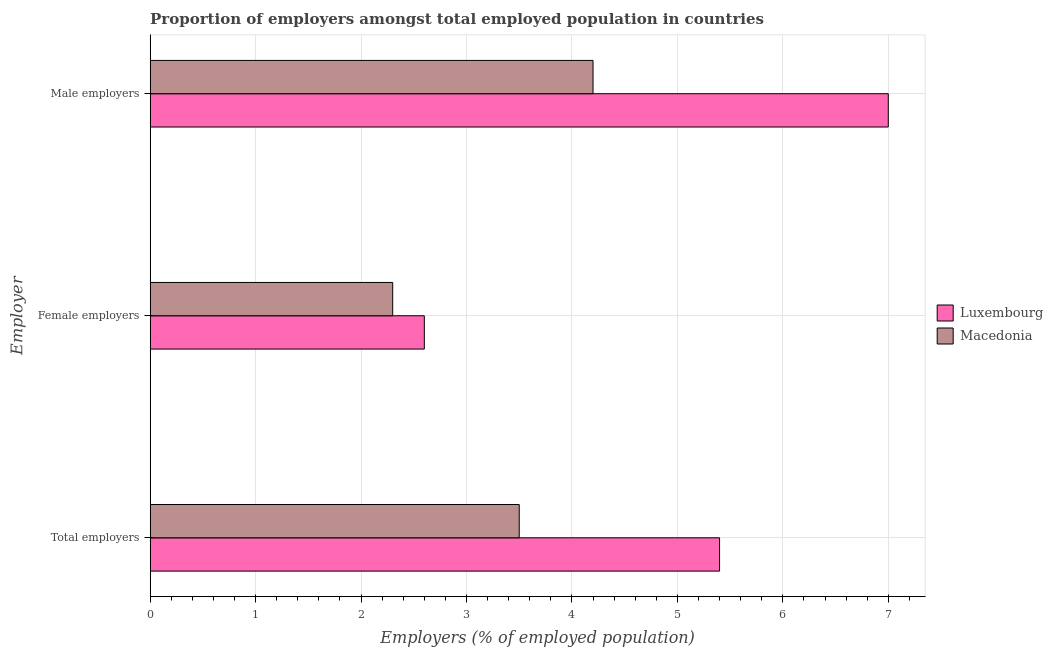How many groups of bars are there?
Provide a succinct answer. 3. Are the number of bars per tick equal to the number of legend labels?
Offer a very short reply. Yes. Are the number of bars on each tick of the Y-axis equal?
Provide a succinct answer. Yes. How many bars are there on the 3rd tick from the top?
Make the answer very short. 2. How many bars are there on the 1st tick from the bottom?
Your answer should be compact. 2. What is the label of the 2nd group of bars from the top?
Offer a terse response. Female employers. What is the percentage of total employers in Macedonia?
Make the answer very short. 3.5. Across all countries, what is the minimum percentage of female employers?
Your answer should be very brief. 2.3. In which country was the percentage of female employers maximum?
Your answer should be very brief. Luxembourg. In which country was the percentage of male employers minimum?
Your response must be concise. Macedonia. What is the total percentage of female employers in the graph?
Offer a very short reply. 4.9. What is the difference between the percentage of total employers in Luxembourg and that in Macedonia?
Give a very brief answer. 1.9. What is the difference between the percentage of female employers in Macedonia and the percentage of male employers in Luxembourg?
Ensure brevity in your answer.  -4.7. What is the average percentage of total employers per country?
Your answer should be compact. 4.45. What is the difference between the percentage of male employers and percentage of female employers in Luxembourg?
Your response must be concise. 4.4. In how many countries, is the percentage of total employers greater than 2.2 %?
Offer a very short reply. 2. What is the ratio of the percentage of total employers in Luxembourg to that in Macedonia?
Your response must be concise. 1.54. Is the percentage of female employers in Macedonia less than that in Luxembourg?
Your answer should be very brief. Yes. Is the difference between the percentage of female employers in Luxembourg and Macedonia greater than the difference between the percentage of male employers in Luxembourg and Macedonia?
Give a very brief answer. No. What is the difference between the highest and the second highest percentage of male employers?
Your response must be concise. 2.8. What is the difference between the highest and the lowest percentage of male employers?
Keep it short and to the point. 2.8. In how many countries, is the percentage of male employers greater than the average percentage of male employers taken over all countries?
Make the answer very short. 1. What does the 1st bar from the top in Female employers represents?
Provide a succinct answer. Macedonia. What does the 1st bar from the bottom in Total employers represents?
Offer a terse response. Luxembourg. How many bars are there?
Provide a short and direct response. 6. Are all the bars in the graph horizontal?
Make the answer very short. Yes. What is the difference between two consecutive major ticks on the X-axis?
Provide a succinct answer. 1. Are the values on the major ticks of X-axis written in scientific E-notation?
Provide a succinct answer. No. Does the graph contain any zero values?
Give a very brief answer. No. Does the graph contain grids?
Your response must be concise. Yes. Where does the legend appear in the graph?
Your answer should be compact. Center right. How many legend labels are there?
Your answer should be very brief. 2. What is the title of the graph?
Provide a short and direct response. Proportion of employers amongst total employed population in countries. Does "Belgium" appear as one of the legend labels in the graph?
Provide a short and direct response. No. What is the label or title of the X-axis?
Your answer should be compact. Employers (% of employed population). What is the label or title of the Y-axis?
Give a very brief answer. Employer. What is the Employers (% of employed population) of Luxembourg in Total employers?
Make the answer very short. 5.4. What is the Employers (% of employed population) of Macedonia in Total employers?
Provide a short and direct response. 3.5. What is the Employers (% of employed population) in Luxembourg in Female employers?
Your answer should be compact. 2.6. What is the Employers (% of employed population) in Macedonia in Female employers?
Give a very brief answer. 2.3. What is the Employers (% of employed population) of Macedonia in Male employers?
Offer a very short reply. 4.2. Across all Employer, what is the maximum Employers (% of employed population) in Luxembourg?
Provide a succinct answer. 7. Across all Employer, what is the maximum Employers (% of employed population) in Macedonia?
Offer a very short reply. 4.2. Across all Employer, what is the minimum Employers (% of employed population) of Luxembourg?
Give a very brief answer. 2.6. Across all Employer, what is the minimum Employers (% of employed population) in Macedonia?
Offer a terse response. 2.3. What is the total Employers (% of employed population) in Luxembourg in the graph?
Keep it short and to the point. 15. What is the difference between the Employers (% of employed population) in Macedonia in Total employers and that in Female employers?
Your answer should be very brief. 1.2. What is the difference between the Employers (% of employed population) in Luxembourg in Total employers and that in Male employers?
Your answer should be compact. -1.6. What is the difference between the Employers (% of employed population) in Luxembourg in Female employers and that in Male employers?
Provide a short and direct response. -4.4. What is the difference between the Employers (% of employed population) of Macedonia in Female employers and that in Male employers?
Provide a succinct answer. -1.9. What is the difference between the Employers (% of employed population) of Luxembourg in Total employers and the Employers (% of employed population) of Macedonia in Female employers?
Your answer should be very brief. 3.1. What is the difference between the Employers (% of employed population) in Luxembourg in Total employers and the Employers (% of employed population) in Macedonia in Male employers?
Make the answer very short. 1.2. What is the difference between the Employers (% of employed population) in Luxembourg in Female employers and the Employers (% of employed population) in Macedonia in Male employers?
Ensure brevity in your answer.  -1.6. What is the average Employers (% of employed population) in Luxembourg per Employer?
Provide a short and direct response. 5. What is the difference between the Employers (% of employed population) in Luxembourg and Employers (% of employed population) in Macedonia in Total employers?
Make the answer very short. 1.9. What is the difference between the Employers (% of employed population) in Luxembourg and Employers (% of employed population) in Macedonia in Female employers?
Your response must be concise. 0.3. What is the ratio of the Employers (% of employed population) of Luxembourg in Total employers to that in Female employers?
Your response must be concise. 2.08. What is the ratio of the Employers (% of employed population) in Macedonia in Total employers to that in Female employers?
Your answer should be compact. 1.52. What is the ratio of the Employers (% of employed population) of Luxembourg in Total employers to that in Male employers?
Ensure brevity in your answer.  0.77. What is the ratio of the Employers (% of employed population) in Macedonia in Total employers to that in Male employers?
Your answer should be very brief. 0.83. What is the ratio of the Employers (% of employed population) of Luxembourg in Female employers to that in Male employers?
Give a very brief answer. 0.37. What is the ratio of the Employers (% of employed population) of Macedonia in Female employers to that in Male employers?
Give a very brief answer. 0.55. What is the difference between the highest and the second highest Employers (% of employed population) of Luxembourg?
Provide a succinct answer. 1.6. What is the difference between the highest and the second highest Employers (% of employed population) in Macedonia?
Provide a short and direct response. 0.7. What is the difference between the highest and the lowest Employers (% of employed population) of Luxembourg?
Your response must be concise. 4.4. What is the difference between the highest and the lowest Employers (% of employed population) in Macedonia?
Your response must be concise. 1.9. 